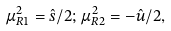Convert formula to latex. <formula><loc_0><loc_0><loc_500><loc_500>\mu _ { R 1 } ^ { 2 } = \hat { s } / 2 ; \, \mu _ { R 2 } ^ { 2 } = - \hat { u } / 2 ,</formula> 